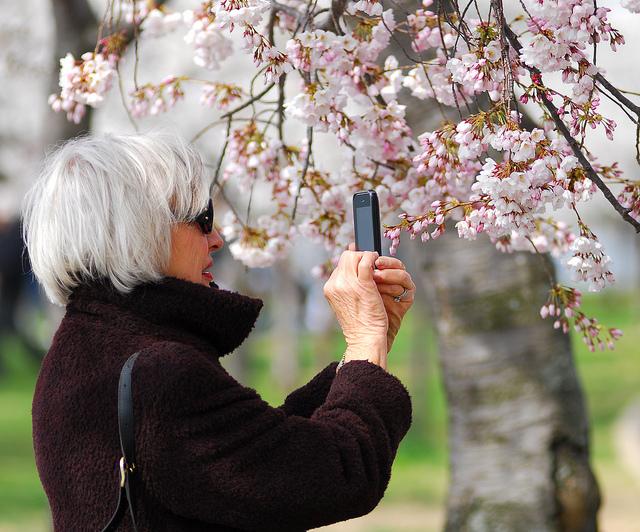Is the female wearing a coat?
Quick response, please. Yes. What kind of blossoms are on the tree?
Give a very brief answer. Cherry. In what type of environment do you think a plant like this would grow?
Short answer required. Temperate. Is the phone a touchscreen?
Write a very short answer. Yes. Why is the woman holding her camera so close to the tree?
Quick response, please. Taking photo. 